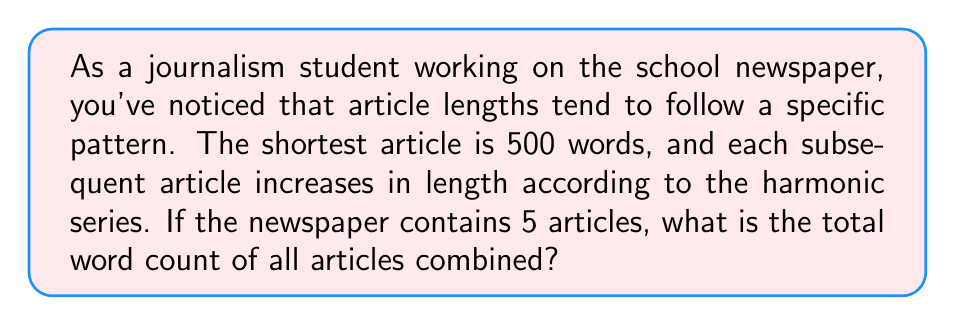Can you answer this question? Let's approach this step-by-step:

1) The harmonic series is defined as:

   $$H_n = 1 + \frac{1}{2} + \frac{1}{3} + \frac{1}{4} + ... + \frac{1}{n}$$

2) In this case, we're starting with 500 words and using the first 5 terms of the harmonic series. So our series will look like:

   $$500 \cdot (1 + \frac{1}{2} + \frac{1}{3} + \frac{1}{4} + \frac{1}{5})$$

3) Let's calculate the sum of the first 5 terms of the harmonic series:

   $$H_5 = 1 + \frac{1}{2} + \frac{1}{3} + \frac{1}{4} + \frac{1}{5} = 2.283333...$$

4) Now, we multiply this by 500:

   $$500 \cdot 2.283333... = 1141.666...$$

5) Rounding to the nearest whole number (as we can't have partial words), we get 1142 words.

Therefore, the total word count for all 5 articles is 1142 words.
Answer: 1142 words 